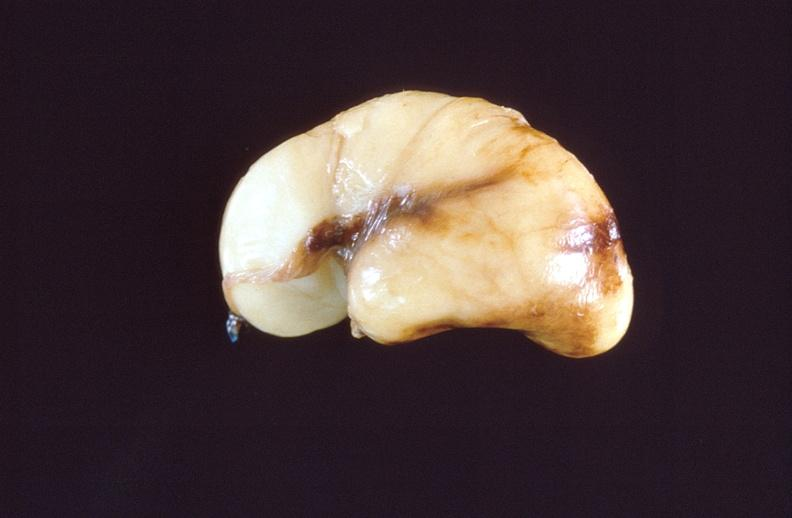what is present?
Answer the question using a single word or phrase. Nervous 